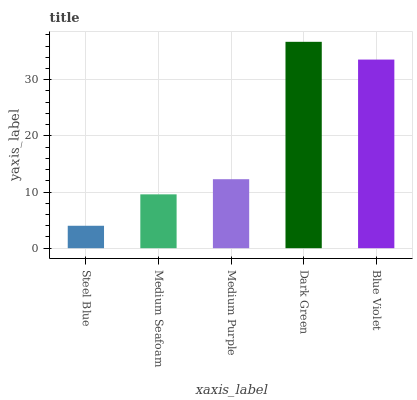Is Steel Blue the minimum?
Answer yes or no. Yes. Is Dark Green the maximum?
Answer yes or no. Yes. Is Medium Seafoam the minimum?
Answer yes or no. No. Is Medium Seafoam the maximum?
Answer yes or no. No. Is Medium Seafoam greater than Steel Blue?
Answer yes or no. Yes. Is Steel Blue less than Medium Seafoam?
Answer yes or no. Yes. Is Steel Blue greater than Medium Seafoam?
Answer yes or no. No. Is Medium Seafoam less than Steel Blue?
Answer yes or no. No. Is Medium Purple the high median?
Answer yes or no. Yes. Is Medium Purple the low median?
Answer yes or no. Yes. Is Medium Seafoam the high median?
Answer yes or no. No. Is Medium Seafoam the low median?
Answer yes or no. No. 